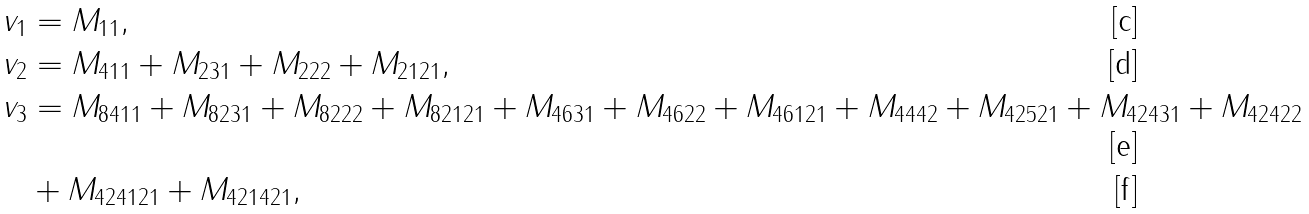Convert formula to latex. <formula><loc_0><loc_0><loc_500><loc_500>v _ { 1 } & = M _ { 1 1 } , \\ v _ { 2 } & = M _ { 4 1 1 } + M _ { 2 3 1 } + M _ { 2 2 2 } + M _ { 2 1 2 1 } , \\ v _ { 3 } & = M _ { 8 4 1 1 } + M _ { 8 2 3 1 } + M _ { 8 2 2 2 } + M _ { 8 2 1 2 1 } + M _ { 4 6 3 1 } + M _ { 4 6 2 2 } + M _ { 4 6 1 2 1 } + M _ { 4 4 4 2 } + M _ { 4 2 5 2 1 } + M _ { 4 2 4 3 1 } + M _ { 4 2 4 2 2 } \\ & + M _ { 4 2 4 1 2 1 } + M _ { 4 2 1 4 2 1 } ,</formula> 